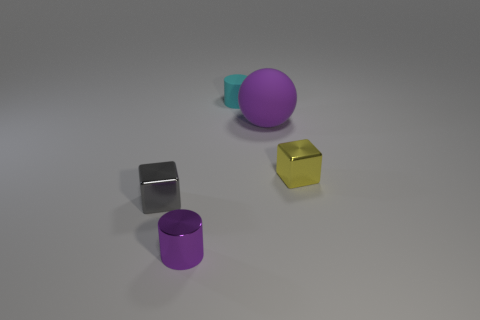There is a yellow thing that is the same shape as the gray metal thing; what is its size? The yellow object, which is a cube like the gray object, appears to be relatively small in size. It is likely a model-sized cube, comparable in dimensions to the gray cube nearby, both fitting within the palm of an adult's hand. 